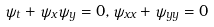Convert formula to latex. <formula><loc_0><loc_0><loc_500><loc_500>\psi _ { t } + \psi _ { x } \psi _ { y } = 0 , \psi _ { x x } + \psi _ { y y } = 0</formula> 